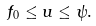Convert formula to latex. <formula><loc_0><loc_0><loc_500><loc_500>f _ { 0 } \leq u \leq \psi .</formula> 